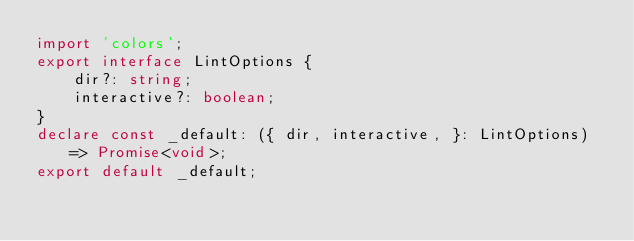<code> <loc_0><loc_0><loc_500><loc_500><_TypeScript_>import 'colors';
export interface LintOptions {
    dir?: string;
    interactive?: boolean;
}
declare const _default: ({ dir, interactive, }: LintOptions) => Promise<void>;
export default _default;
</code> 